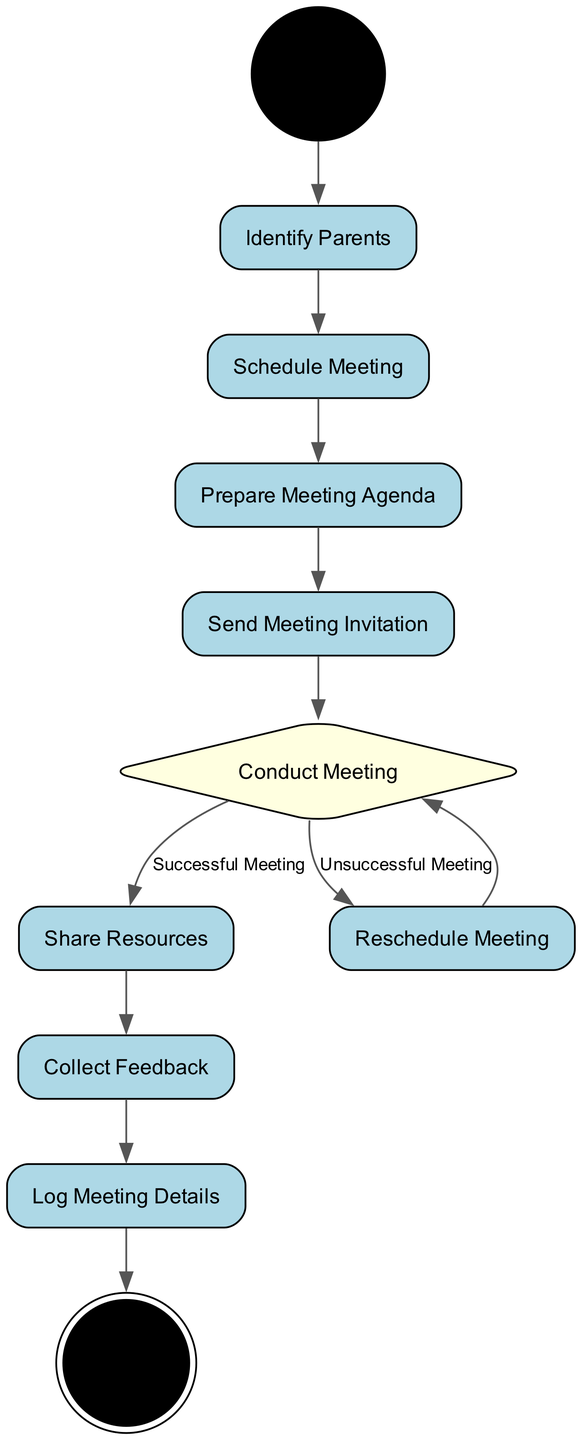What is the first action node in the diagram? The first action node that follows the initial node is "Identify Parents". It is connected directly to the "Start" node, which signifies the beginning of the process.
Answer: Identify Parents How many action nodes are present in the diagram? The action nodes in the diagram are "Identify Parents", "Schedule Meeting", "Prepare Meeting Agenda", "Send Meeting Invitation", "Share Resources", "Reschedule Meeting", and "Collect Feedback". This totals to seven action nodes.
Answer: Seven What decision follows the "Conduct Meeting" node? The "Conduct Meeting" node leads to a decision point that assesses whether the meeting was successful or unsuccessful. The two outcomes are "Share Resources" for a successful meeting and "Reschedule Meeting" for an unsuccessful meeting.
Answer: Share Resources or Reschedule Meeting What happens after sharing resources? After the "Share Resources" node, the next action node is "Collect Feedback". This indicates that once resources are shared, gathering feedback is the subsequent step in the process.
Answer: Collect Feedback What is the final action before ending the diagram? The final action node before reaching the "End" node is "Log Meeting Details". This node illustrates that recording the meeting details is the last step in the entire process.
Answer: Log Meeting Details In the case of an unsuccessful meeting, what step follows "Conduct Meeting"? If the meeting is deemed unsuccessful, the flow leads to "Reschedule Meeting", indicating that an alternative meeting should be arranged. After this, the process returns to "Conduct Meeting".
Answer: Reschedule Meeting How many transitions are there originating from "Conduct Meeting"? There are two transitions originating from the "Conduct Meeting" node; one leads to "Share Resources" and the other to "Reschedule Meeting", based on whether the meeting was successful or unsuccessful.
Answer: Two What action is taken after collecting feedback? The step that follows "Collect Feedback" is "Log Meeting Details". This action indicates that feedback is documented as the next vital part of the process.
Answer: Log Meeting Details 